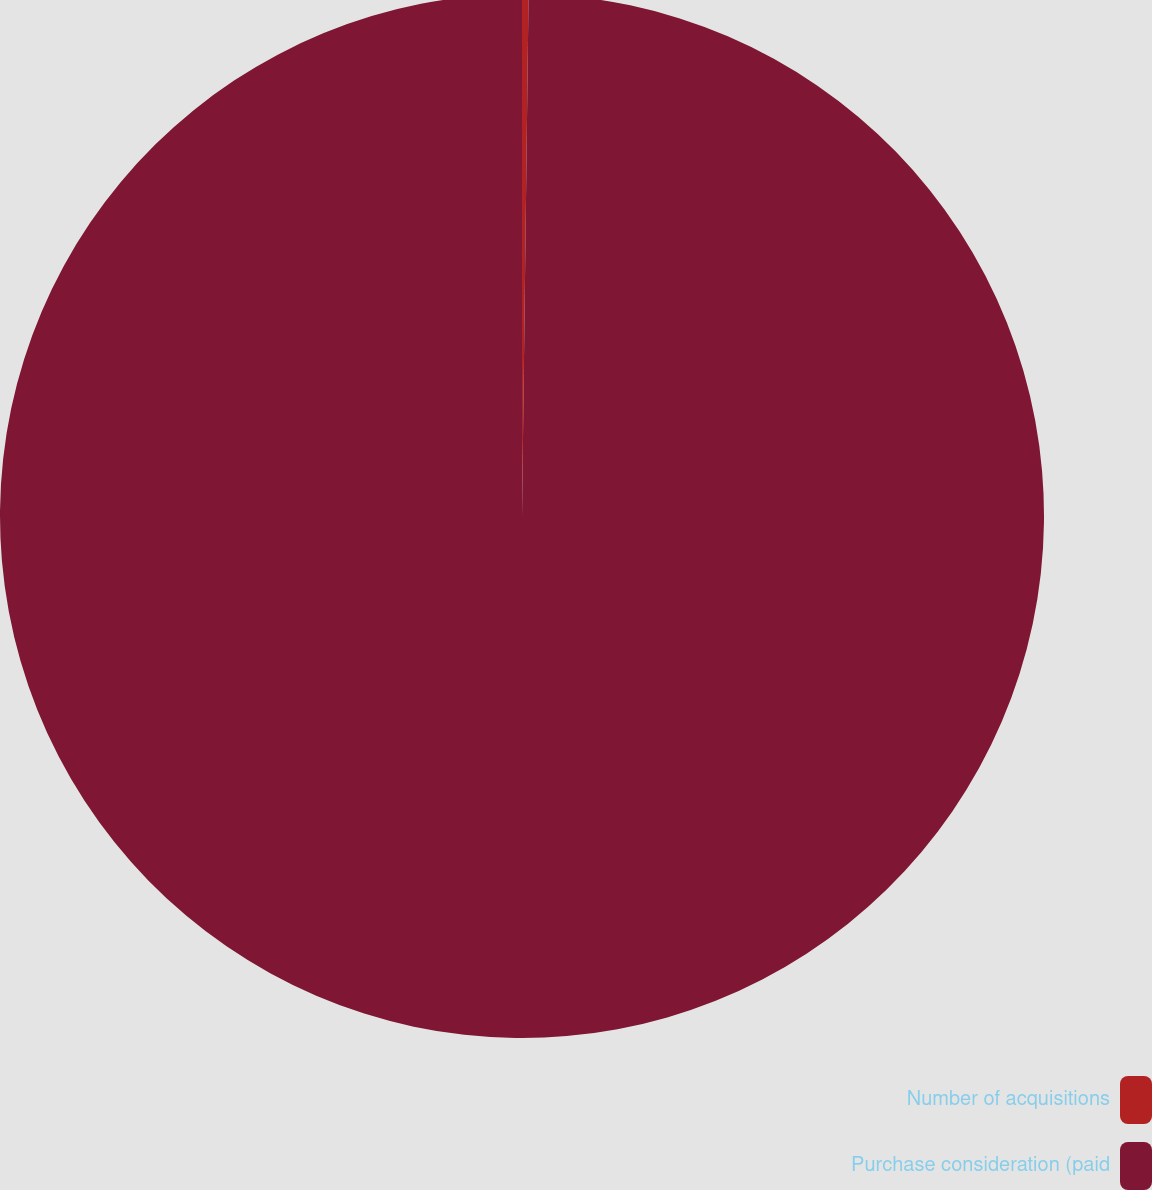Convert chart to OTSL. <chart><loc_0><loc_0><loc_500><loc_500><pie_chart><fcel>Number of acquisitions<fcel>Purchase consideration (paid<nl><fcel>0.2%<fcel>99.8%<nl></chart> 